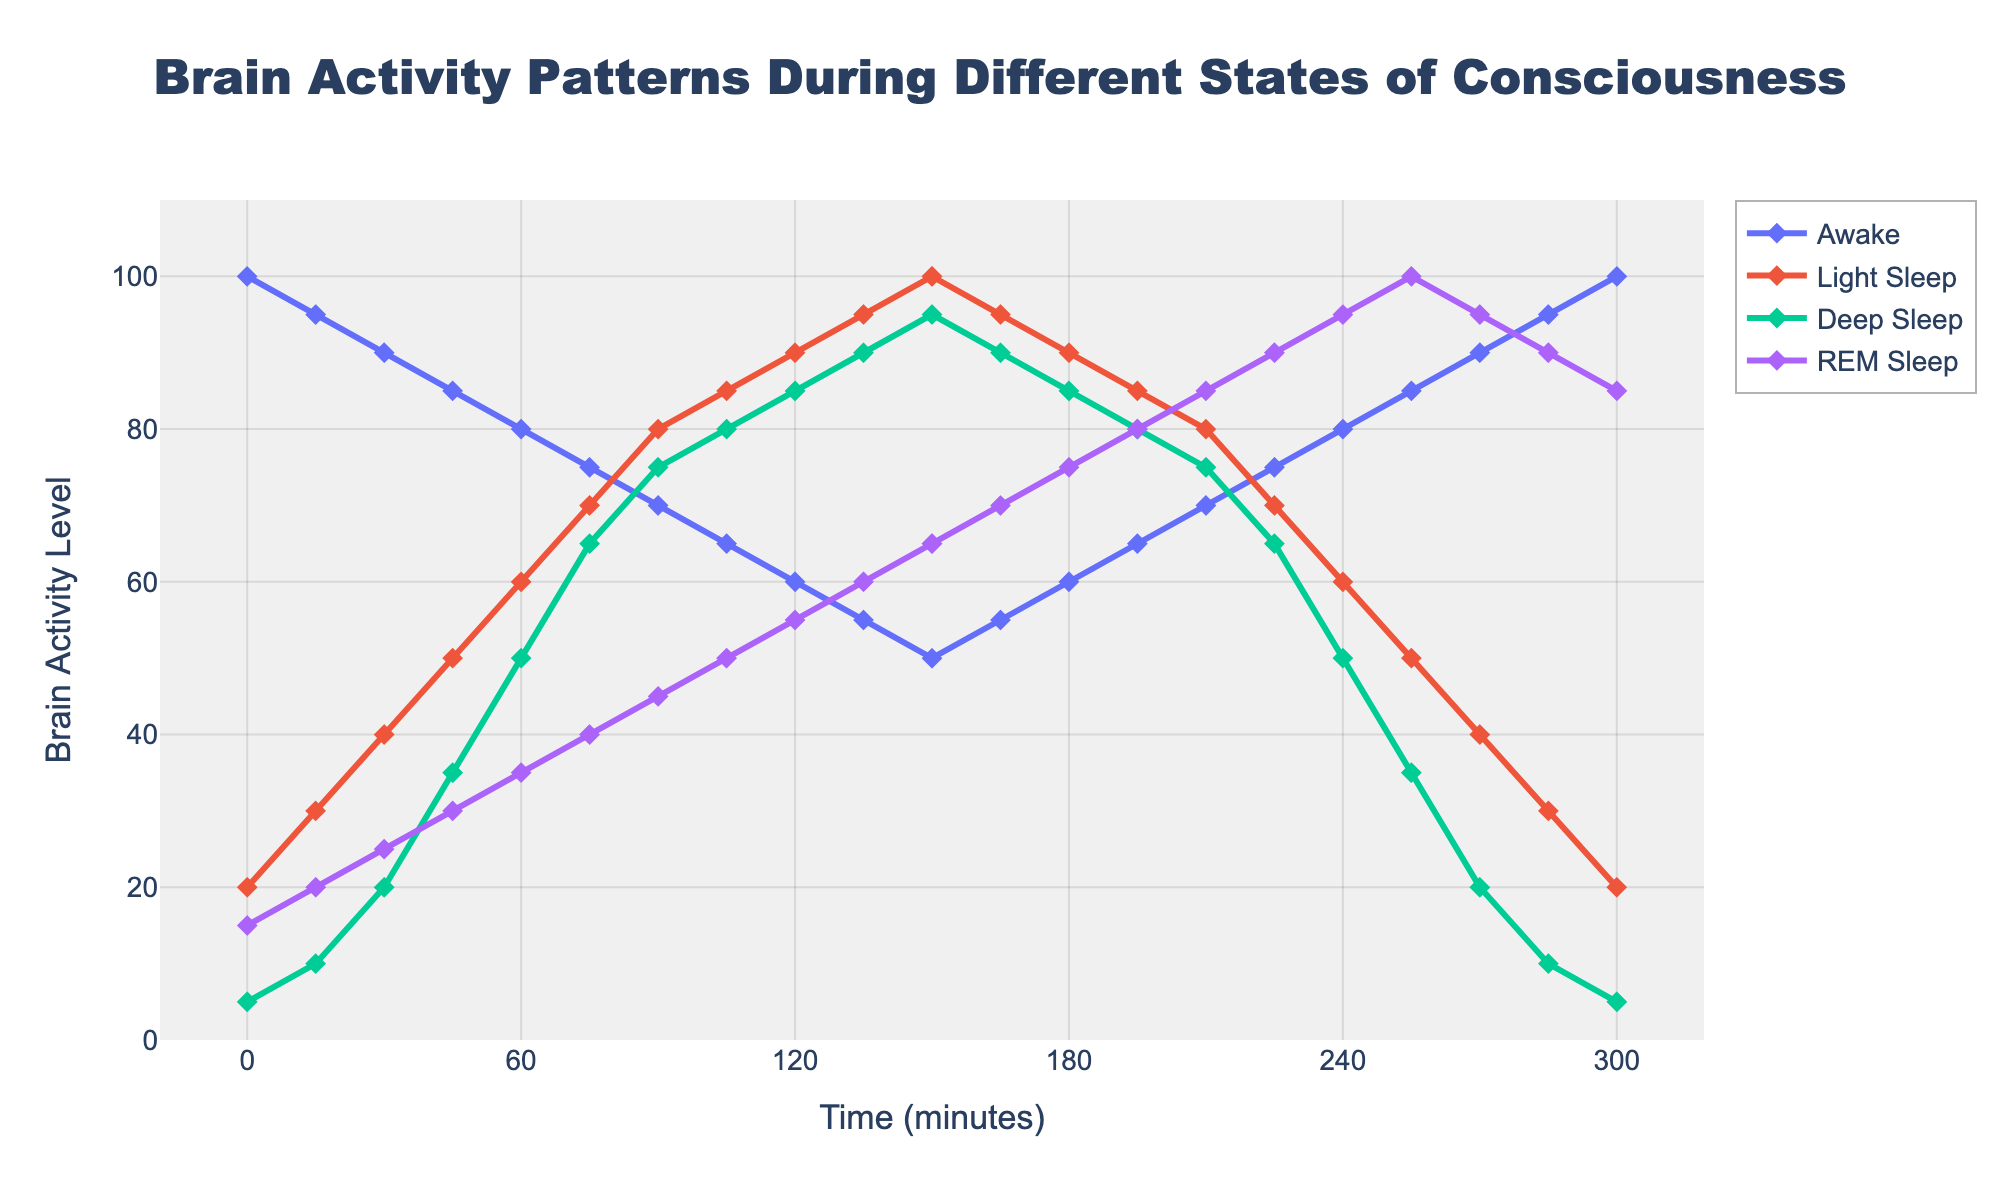What's the level of brain activity for the Awake state at 60 minutes? Look at the 'Awake' line on the graph and find the value corresponding to 60 minutes. The value is 80.
Answer: 80 Which state has the highest brain activity level at 135 minutes? Observe the lines at the 135-minute mark. 'Deep Sleep' has the highest value at 95.
Answer: Deep Sleep At what time do Light Sleep and REM Sleep have the same brain activity level? Identify when the 'Light Sleep' and 'REM Sleep' lines intersect. They intersect at 225 minutes with both having a level of 65.
Answer: 225 minutes What is the average brain activity level of the Deep Sleep state at 90 and 210 minutes? Find the values for 'Deep Sleep' at 90 and 210 minutes: 75 and 75 respectively. The average is (75 + 75) / 2 = 75.
Answer: 75 Between which time intervals does the Awake state show a consistent decrease in brain activity levels? Observe the 'Awake' line and identify intervals where the slope is consistently downward. The 'Awake' state shows a consistent decrease from 0 to 150 minutes.
Answer: 0 to 150 minutes Calculate the difference in REM Sleep brain activity between 0 and 240 minutes. Find the values for 'REM Sleep' at 0 and 240 minutes: 15 and 95 respectively. The difference is 95 - 15 = 80.
Answer: 80 Which state shows the steepest increase in brain activity between consecutive time intervals? Observe the slopes of the lines between consecutive intervals. 'Deep Sleep' shows a steep increase from 45 to 105 minutes.
Answer: Deep Sleep How does the brain activity level in Deep Sleep compare to REM Sleep at 165 minutes? Compare the two values at 165 minutes: 'Deep Sleep' is 90 and 'REM Sleep' is 70. 'Deep Sleep' has a higher value.
Answer: Deep Sleep higher What is the brain activity level for Light Sleep at its lowest point? Find the lowest point of the 'Light Sleep' line on the graph. The lowest value is 20 at 0 and 300 minutes.
Answer: 20 How does the pattern of brain activity for Deep Sleep change over time? Observe the 'Deep Sleep' line from beginning to end. It increases steadily until 150 minutes, then decreases again.
Answer: Increases then decreases 